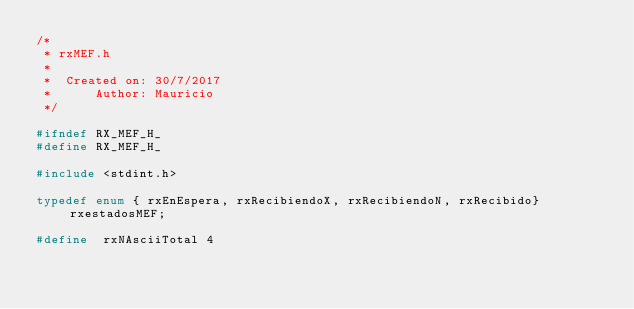Convert code to text. <code><loc_0><loc_0><loc_500><loc_500><_C_>/*
 * rxMEF.h
 *
 *  Created on: 30/7/2017
 *      Author: Mauricio
 */

#ifndef RX_MEF_H_
#define RX_MEF_H_

#include <stdint.h>

typedef enum { rxEnEspera, rxRecibiendoX, rxRecibiendoN, rxRecibido} rxestadosMEF;

#define  rxNAsciiTotal 4
</code> 